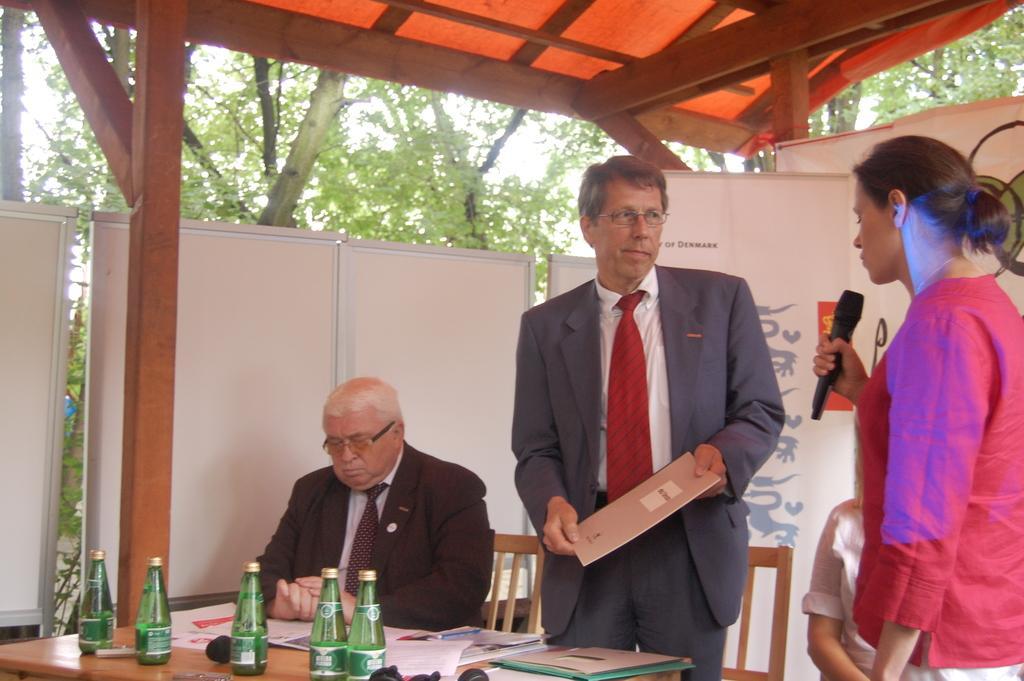Describe this image in one or two sentences. on the background we can see trees, whiteboards. Here we can see two persons standing in front of a table and on the table we can see files, papers,bottles. We can see one man wearing spectacles sitting on a chair. She is holding a mike in her hand. 